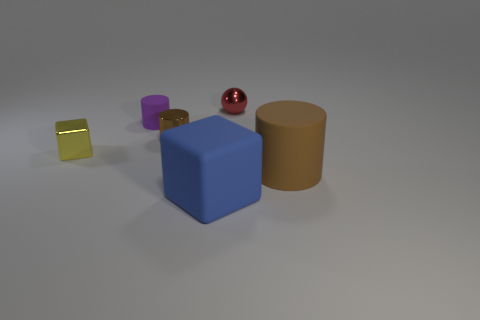There is a red object behind the yellow thing; does it have the same shape as the large blue matte thing? No, the red object does not have the same shape as the large blue one; while the red object appears to be a sphere, the blue object is distinctly cube-shaped. 